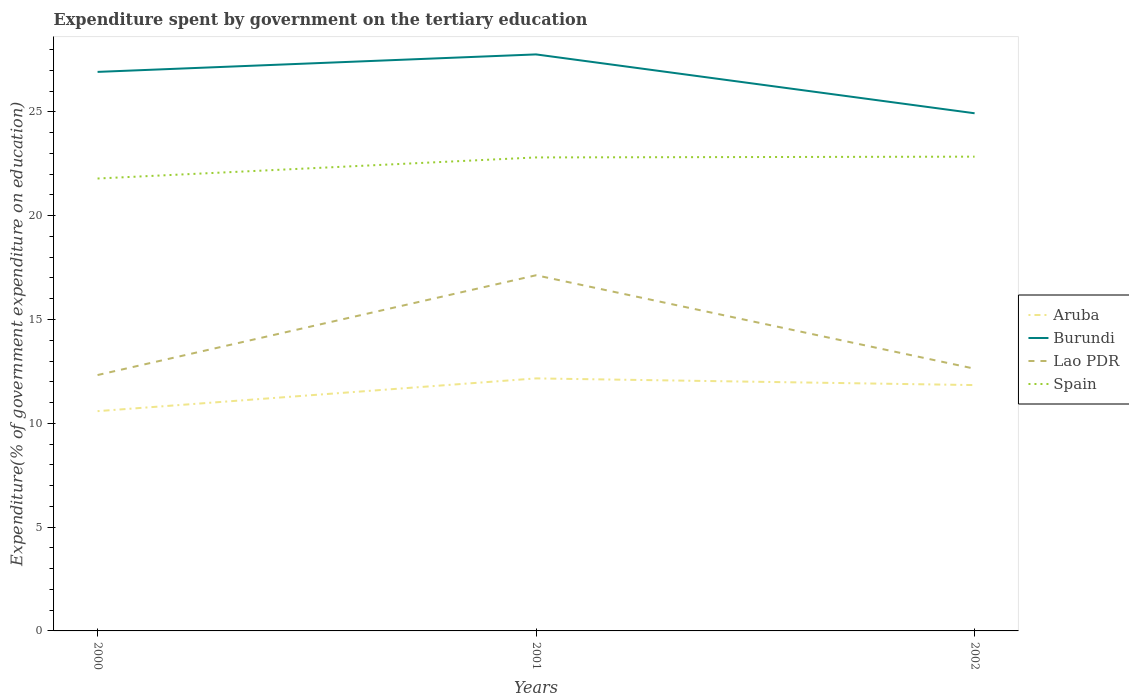How many different coloured lines are there?
Keep it short and to the point. 4. Across all years, what is the maximum expenditure spent by government on the tertiary education in Burundi?
Give a very brief answer. 24.93. What is the total expenditure spent by government on the tertiary education in Spain in the graph?
Provide a short and direct response. -0.04. What is the difference between the highest and the second highest expenditure spent by government on the tertiary education in Spain?
Your answer should be compact. 1.05. What is the difference between the highest and the lowest expenditure spent by government on the tertiary education in Aruba?
Your answer should be very brief. 2. How many lines are there?
Give a very brief answer. 4. What is the difference between two consecutive major ticks on the Y-axis?
Your answer should be compact. 5. Are the values on the major ticks of Y-axis written in scientific E-notation?
Give a very brief answer. No. Does the graph contain grids?
Keep it short and to the point. No. Where does the legend appear in the graph?
Offer a very short reply. Center right. What is the title of the graph?
Provide a short and direct response. Expenditure spent by government on the tertiary education. Does "West Bank and Gaza" appear as one of the legend labels in the graph?
Give a very brief answer. No. What is the label or title of the X-axis?
Your answer should be compact. Years. What is the label or title of the Y-axis?
Provide a short and direct response. Expenditure(% of government expenditure on education). What is the Expenditure(% of government expenditure on education) in Aruba in 2000?
Make the answer very short. 10.58. What is the Expenditure(% of government expenditure on education) in Burundi in 2000?
Make the answer very short. 26.92. What is the Expenditure(% of government expenditure on education) of Lao PDR in 2000?
Your answer should be very brief. 12.32. What is the Expenditure(% of government expenditure on education) in Spain in 2000?
Keep it short and to the point. 21.79. What is the Expenditure(% of government expenditure on education) of Aruba in 2001?
Give a very brief answer. 12.16. What is the Expenditure(% of government expenditure on education) in Burundi in 2001?
Provide a succinct answer. 27.77. What is the Expenditure(% of government expenditure on education) of Lao PDR in 2001?
Offer a very short reply. 17.13. What is the Expenditure(% of government expenditure on education) of Spain in 2001?
Offer a terse response. 22.8. What is the Expenditure(% of government expenditure on education) in Aruba in 2002?
Your response must be concise. 11.84. What is the Expenditure(% of government expenditure on education) of Burundi in 2002?
Give a very brief answer. 24.93. What is the Expenditure(% of government expenditure on education) in Lao PDR in 2002?
Provide a short and direct response. 12.63. What is the Expenditure(% of government expenditure on education) in Spain in 2002?
Your answer should be compact. 22.84. Across all years, what is the maximum Expenditure(% of government expenditure on education) in Aruba?
Your answer should be compact. 12.16. Across all years, what is the maximum Expenditure(% of government expenditure on education) of Burundi?
Keep it short and to the point. 27.77. Across all years, what is the maximum Expenditure(% of government expenditure on education) of Lao PDR?
Give a very brief answer. 17.13. Across all years, what is the maximum Expenditure(% of government expenditure on education) of Spain?
Provide a succinct answer. 22.84. Across all years, what is the minimum Expenditure(% of government expenditure on education) in Aruba?
Keep it short and to the point. 10.58. Across all years, what is the minimum Expenditure(% of government expenditure on education) of Burundi?
Ensure brevity in your answer.  24.93. Across all years, what is the minimum Expenditure(% of government expenditure on education) of Lao PDR?
Keep it short and to the point. 12.32. Across all years, what is the minimum Expenditure(% of government expenditure on education) of Spain?
Keep it short and to the point. 21.79. What is the total Expenditure(% of government expenditure on education) of Aruba in the graph?
Keep it short and to the point. 34.59. What is the total Expenditure(% of government expenditure on education) in Burundi in the graph?
Give a very brief answer. 79.62. What is the total Expenditure(% of government expenditure on education) in Lao PDR in the graph?
Make the answer very short. 42.08. What is the total Expenditure(% of government expenditure on education) in Spain in the graph?
Your answer should be very brief. 67.44. What is the difference between the Expenditure(% of government expenditure on education) of Aruba in 2000 and that in 2001?
Offer a very short reply. -1.58. What is the difference between the Expenditure(% of government expenditure on education) in Burundi in 2000 and that in 2001?
Your response must be concise. -0.84. What is the difference between the Expenditure(% of government expenditure on education) in Lao PDR in 2000 and that in 2001?
Your answer should be very brief. -4.81. What is the difference between the Expenditure(% of government expenditure on education) of Spain in 2000 and that in 2001?
Your response must be concise. -1.02. What is the difference between the Expenditure(% of government expenditure on education) of Aruba in 2000 and that in 2002?
Offer a very short reply. -1.26. What is the difference between the Expenditure(% of government expenditure on education) of Burundi in 2000 and that in 2002?
Provide a succinct answer. 1.99. What is the difference between the Expenditure(% of government expenditure on education) in Lao PDR in 2000 and that in 2002?
Give a very brief answer. -0.3. What is the difference between the Expenditure(% of government expenditure on education) in Spain in 2000 and that in 2002?
Provide a short and direct response. -1.05. What is the difference between the Expenditure(% of government expenditure on education) of Aruba in 2001 and that in 2002?
Provide a short and direct response. 0.32. What is the difference between the Expenditure(% of government expenditure on education) of Burundi in 2001 and that in 2002?
Your answer should be very brief. 2.83. What is the difference between the Expenditure(% of government expenditure on education) in Lao PDR in 2001 and that in 2002?
Provide a short and direct response. 4.5. What is the difference between the Expenditure(% of government expenditure on education) in Spain in 2001 and that in 2002?
Your response must be concise. -0.04. What is the difference between the Expenditure(% of government expenditure on education) of Aruba in 2000 and the Expenditure(% of government expenditure on education) of Burundi in 2001?
Your response must be concise. -17.18. What is the difference between the Expenditure(% of government expenditure on education) in Aruba in 2000 and the Expenditure(% of government expenditure on education) in Lao PDR in 2001?
Provide a short and direct response. -6.55. What is the difference between the Expenditure(% of government expenditure on education) in Aruba in 2000 and the Expenditure(% of government expenditure on education) in Spain in 2001?
Make the answer very short. -12.22. What is the difference between the Expenditure(% of government expenditure on education) in Burundi in 2000 and the Expenditure(% of government expenditure on education) in Lao PDR in 2001?
Offer a terse response. 9.79. What is the difference between the Expenditure(% of government expenditure on education) in Burundi in 2000 and the Expenditure(% of government expenditure on education) in Spain in 2001?
Your response must be concise. 4.12. What is the difference between the Expenditure(% of government expenditure on education) of Lao PDR in 2000 and the Expenditure(% of government expenditure on education) of Spain in 2001?
Offer a terse response. -10.48. What is the difference between the Expenditure(% of government expenditure on education) of Aruba in 2000 and the Expenditure(% of government expenditure on education) of Burundi in 2002?
Your answer should be compact. -14.35. What is the difference between the Expenditure(% of government expenditure on education) of Aruba in 2000 and the Expenditure(% of government expenditure on education) of Lao PDR in 2002?
Offer a very short reply. -2.04. What is the difference between the Expenditure(% of government expenditure on education) of Aruba in 2000 and the Expenditure(% of government expenditure on education) of Spain in 2002?
Keep it short and to the point. -12.26. What is the difference between the Expenditure(% of government expenditure on education) in Burundi in 2000 and the Expenditure(% of government expenditure on education) in Lao PDR in 2002?
Give a very brief answer. 14.3. What is the difference between the Expenditure(% of government expenditure on education) of Burundi in 2000 and the Expenditure(% of government expenditure on education) of Spain in 2002?
Your answer should be very brief. 4.08. What is the difference between the Expenditure(% of government expenditure on education) in Lao PDR in 2000 and the Expenditure(% of government expenditure on education) in Spain in 2002?
Your answer should be very brief. -10.52. What is the difference between the Expenditure(% of government expenditure on education) of Aruba in 2001 and the Expenditure(% of government expenditure on education) of Burundi in 2002?
Provide a short and direct response. -12.77. What is the difference between the Expenditure(% of government expenditure on education) of Aruba in 2001 and the Expenditure(% of government expenditure on education) of Lao PDR in 2002?
Make the answer very short. -0.47. What is the difference between the Expenditure(% of government expenditure on education) in Aruba in 2001 and the Expenditure(% of government expenditure on education) in Spain in 2002?
Keep it short and to the point. -10.68. What is the difference between the Expenditure(% of government expenditure on education) of Burundi in 2001 and the Expenditure(% of government expenditure on education) of Lao PDR in 2002?
Offer a very short reply. 15.14. What is the difference between the Expenditure(% of government expenditure on education) of Burundi in 2001 and the Expenditure(% of government expenditure on education) of Spain in 2002?
Provide a short and direct response. 4.92. What is the difference between the Expenditure(% of government expenditure on education) of Lao PDR in 2001 and the Expenditure(% of government expenditure on education) of Spain in 2002?
Make the answer very short. -5.71. What is the average Expenditure(% of government expenditure on education) in Aruba per year?
Your answer should be compact. 11.53. What is the average Expenditure(% of government expenditure on education) in Burundi per year?
Offer a terse response. 26.54. What is the average Expenditure(% of government expenditure on education) of Lao PDR per year?
Make the answer very short. 14.03. What is the average Expenditure(% of government expenditure on education) in Spain per year?
Ensure brevity in your answer.  22.48. In the year 2000, what is the difference between the Expenditure(% of government expenditure on education) of Aruba and Expenditure(% of government expenditure on education) of Burundi?
Your response must be concise. -16.34. In the year 2000, what is the difference between the Expenditure(% of government expenditure on education) of Aruba and Expenditure(% of government expenditure on education) of Lao PDR?
Make the answer very short. -1.74. In the year 2000, what is the difference between the Expenditure(% of government expenditure on education) of Aruba and Expenditure(% of government expenditure on education) of Spain?
Provide a short and direct response. -11.2. In the year 2000, what is the difference between the Expenditure(% of government expenditure on education) in Burundi and Expenditure(% of government expenditure on education) in Lao PDR?
Give a very brief answer. 14.6. In the year 2000, what is the difference between the Expenditure(% of government expenditure on education) of Burundi and Expenditure(% of government expenditure on education) of Spain?
Make the answer very short. 5.14. In the year 2000, what is the difference between the Expenditure(% of government expenditure on education) in Lao PDR and Expenditure(% of government expenditure on education) in Spain?
Keep it short and to the point. -9.47. In the year 2001, what is the difference between the Expenditure(% of government expenditure on education) in Aruba and Expenditure(% of government expenditure on education) in Burundi?
Offer a very short reply. -15.6. In the year 2001, what is the difference between the Expenditure(% of government expenditure on education) in Aruba and Expenditure(% of government expenditure on education) in Lao PDR?
Your answer should be compact. -4.97. In the year 2001, what is the difference between the Expenditure(% of government expenditure on education) in Aruba and Expenditure(% of government expenditure on education) in Spain?
Offer a very short reply. -10.64. In the year 2001, what is the difference between the Expenditure(% of government expenditure on education) of Burundi and Expenditure(% of government expenditure on education) of Lao PDR?
Provide a short and direct response. 10.64. In the year 2001, what is the difference between the Expenditure(% of government expenditure on education) in Burundi and Expenditure(% of government expenditure on education) in Spain?
Keep it short and to the point. 4.96. In the year 2001, what is the difference between the Expenditure(% of government expenditure on education) of Lao PDR and Expenditure(% of government expenditure on education) of Spain?
Provide a short and direct response. -5.67. In the year 2002, what is the difference between the Expenditure(% of government expenditure on education) in Aruba and Expenditure(% of government expenditure on education) in Burundi?
Your answer should be very brief. -13.09. In the year 2002, what is the difference between the Expenditure(% of government expenditure on education) of Aruba and Expenditure(% of government expenditure on education) of Lao PDR?
Offer a terse response. -0.79. In the year 2002, what is the difference between the Expenditure(% of government expenditure on education) in Aruba and Expenditure(% of government expenditure on education) in Spain?
Your response must be concise. -11. In the year 2002, what is the difference between the Expenditure(% of government expenditure on education) in Burundi and Expenditure(% of government expenditure on education) in Lao PDR?
Provide a short and direct response. 12.3. In the year 2002, what is the difference between the Expenditure(% of government expenditure on education) of Burundi and Expenditure(% of government expenditure on education) of Spain?
Offer a terse response. 2.09. In the year 2002, what is the difference between the Expenditure(% of government expenditure on education) in Lao PDR and Expenditure(% of government expenditure on education) in Spain?
Keep it short and to the point. -10.21. What is the ratio of the Expenditure(% of government expenditure on education) of Aruba in 2000 to that in 2001?
Make the answer very short. 0.87. What is the ratio of the Expenditure(% of government expenditure on education) of Burundi in 2000 to that in 2001?
Offer a terse response. 0.97. What is the ratio of the Expenditure(% of government expenditure on education) in Lao PDR in 2000 to that in 2001?
Offer a terse response. 0.72. What is the ratio of the Expenditure(% of government expenditure on education) of Spain in 2000 to that in 2001?
Offer a terse response. 0.96. What is the ratio of the Expenditure(% of government expenditure on education) of Aruba in 2000 to that in 2002?
Offer a very short reply. 0.89. What is the ratio of the Expenditure(% of government expenditure on education) of Burundi in 2000 to that in 2002?
Offer a terse response. 1.08. What is the ratio of the Expenditure(% of government expenditure on education) in Lao PDR in 2000 to that in 2002?
Offer a very short reply. 0.98. What is the ratio of the Expenditure(% of government expenditure on education) of Spain in 2000 to that in 2002?
Your answer should be compact. 0.95. What is the ratio of the Expenditure(% of government expenditure on education) of Aruba in 2001 to that in 2002?
Make the answer very short. 1.03. What is the ratio of the Expenditure(% of government expenditure on education) in Burundi in 2001 to that in 2002?
Ensure brevity in your answer.  1.11. What is the ratio of the Expenditure(% of government expenditure on education) in Lao PDR in 2001 to that in 2002?
Give a very brief answer. 1.36. What is the ratio of the Expenditure(% of government expenditure on education) in Spain in 2001 to that in 2002?
Offer a terse response. 1. What is the difference between the highest and the second highest Expenditure(% of government expenditure on education) in Aruba?
Make the answer very short. 0.32. What is the difference between the highest and the second highest Expenditure(% of government expenditure on education) in Burundi?
Your answer should be compact. 0.84. What is the difference between the highest and the second highest Expenditure(% of government expenditure on education) of Lao PDR?
Provide a succinct answer. 4.5. What is the difference between the highest and the second highest Expenditure(% of government expenditure on education) in Spain?
Keep it short and to the point. 0.04. What is the difference between the highest and the lowest Expenditure(% of government expenditure on education) in Aruba?
Your answer should be very brief. 1.58. What is the difference between the highest and the lowest Expenditure(% of government expenditure on education) in Burundi?
Offer a terse response. 2.83. What is the difference between the highest and the lowest Expenditure(% of government expenditure on education) of Lao PDR?
Ensure brevity in your answer.  4.81. What is the difference between the highest and the lowest Expenditure(% of government expenditure on education) in Spain?
Offer a very short reply. 1.05. 